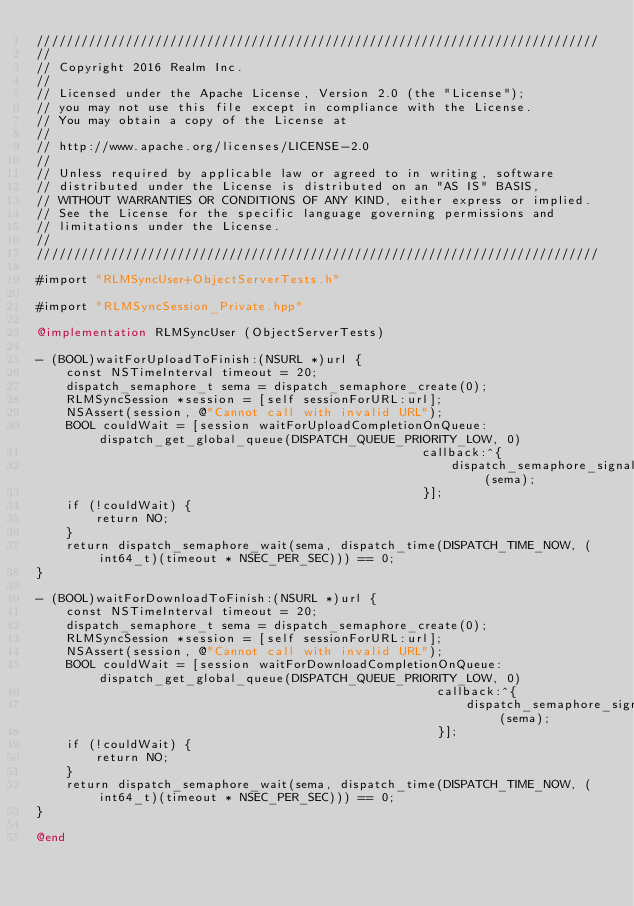<code> <loc_0><loc_0><loc_500><loc_500><_ObjectiveC_>////////////////////////////////////////////////////////////////////////////
//
// Copyright 2016 Realm Inc.
//
// Licensed under the Apache License, Version 2.0 (the "License");
// you may not use this file except in compliance with the License.
// You may obtain a copy of the License at
//
// http://www.apache.org/licenses/LICENSE-2.0
//
// Unless required by applicable law or agreed to in writing, software
// distributed under the License is distributed on an "AS IS" BASIS,
// WITHOUT WARRANTIES OR CONDITIONS OF ANY KIND, either express or implied.
// See the License for the specific language governing permissions and
// limitations under the License.
//
////////////////////////////////////////////////////////////////////////////

#import "RLMSyncUser+ObjectServerTests.h"

#import "RLMSyncSession_Private.hpp"

@implementation RLMSyncUser (ObjectServerTests)

- (BOOL)waitForUploadToFinish:(NSURL *)url {
    const NSTimeInterval timeout = 20;
    dispatch_semaphore_t sema = dispatch_semaphore_create(0);
    RLMSyncSession *session = [self sessionForURL:url];
    NSAssert(session, @"Cannot call with invalid URL");
    BOOL couldWait = [session waitForUploadCompletionOnQueue:dispatch_get_global_queue(DISPATCH_QUEUE_PRIORITY_LOW, 0)
                                                    callback:^{
                                                        dispatch_semaphore_signal(sema);
                                                    }];
    if (!couldWait) {
        return NO;
    }
    return dispatch_semaphore_wait(sema, dispatch_time(DISPATCH_TIME_NOW, (int64_t)(timeout * NSEC_PER_SEC))) == 0;
}

- (BOOL)waitForDownloadToFinish:(NSURL *)url {
    const NSTimeInterval timeout = 20;
    dispatch_semaphore_t sema = dispatch_semaphore_create(0);
    RLMSyncSession *session = [self sessionForURL:url];
    NSAssert(session, @"Cannot call with invalid URL");
    BOOL couldWait = [session waitForDownloadCompletionOnQueue:dispatch_get_global_queue(DISPATCH_QUEUE_PRIORITY_LOW, 0)
                                                      callback:^{
                                                          dispatch_semaphore_signal(sema);
                                                      }];
    if (!couldWait) {
        return NO;
    }
    return dispatch_semaphore_wait(sema, dispatch_time(DISPATCH_TIME_NOW, (int64_t)(timeout * NSEC_PER_SEC))) == 0;
}

@end
</code> 